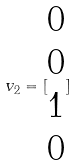Convert formula to latex. <formula><loc_0><loc_0><loc_500><loc_500>v _ { 2 } = [ \begin{matrix} 0 \\ 0 \\ 1 \\ 0 \end{matrix} ]</formula> 